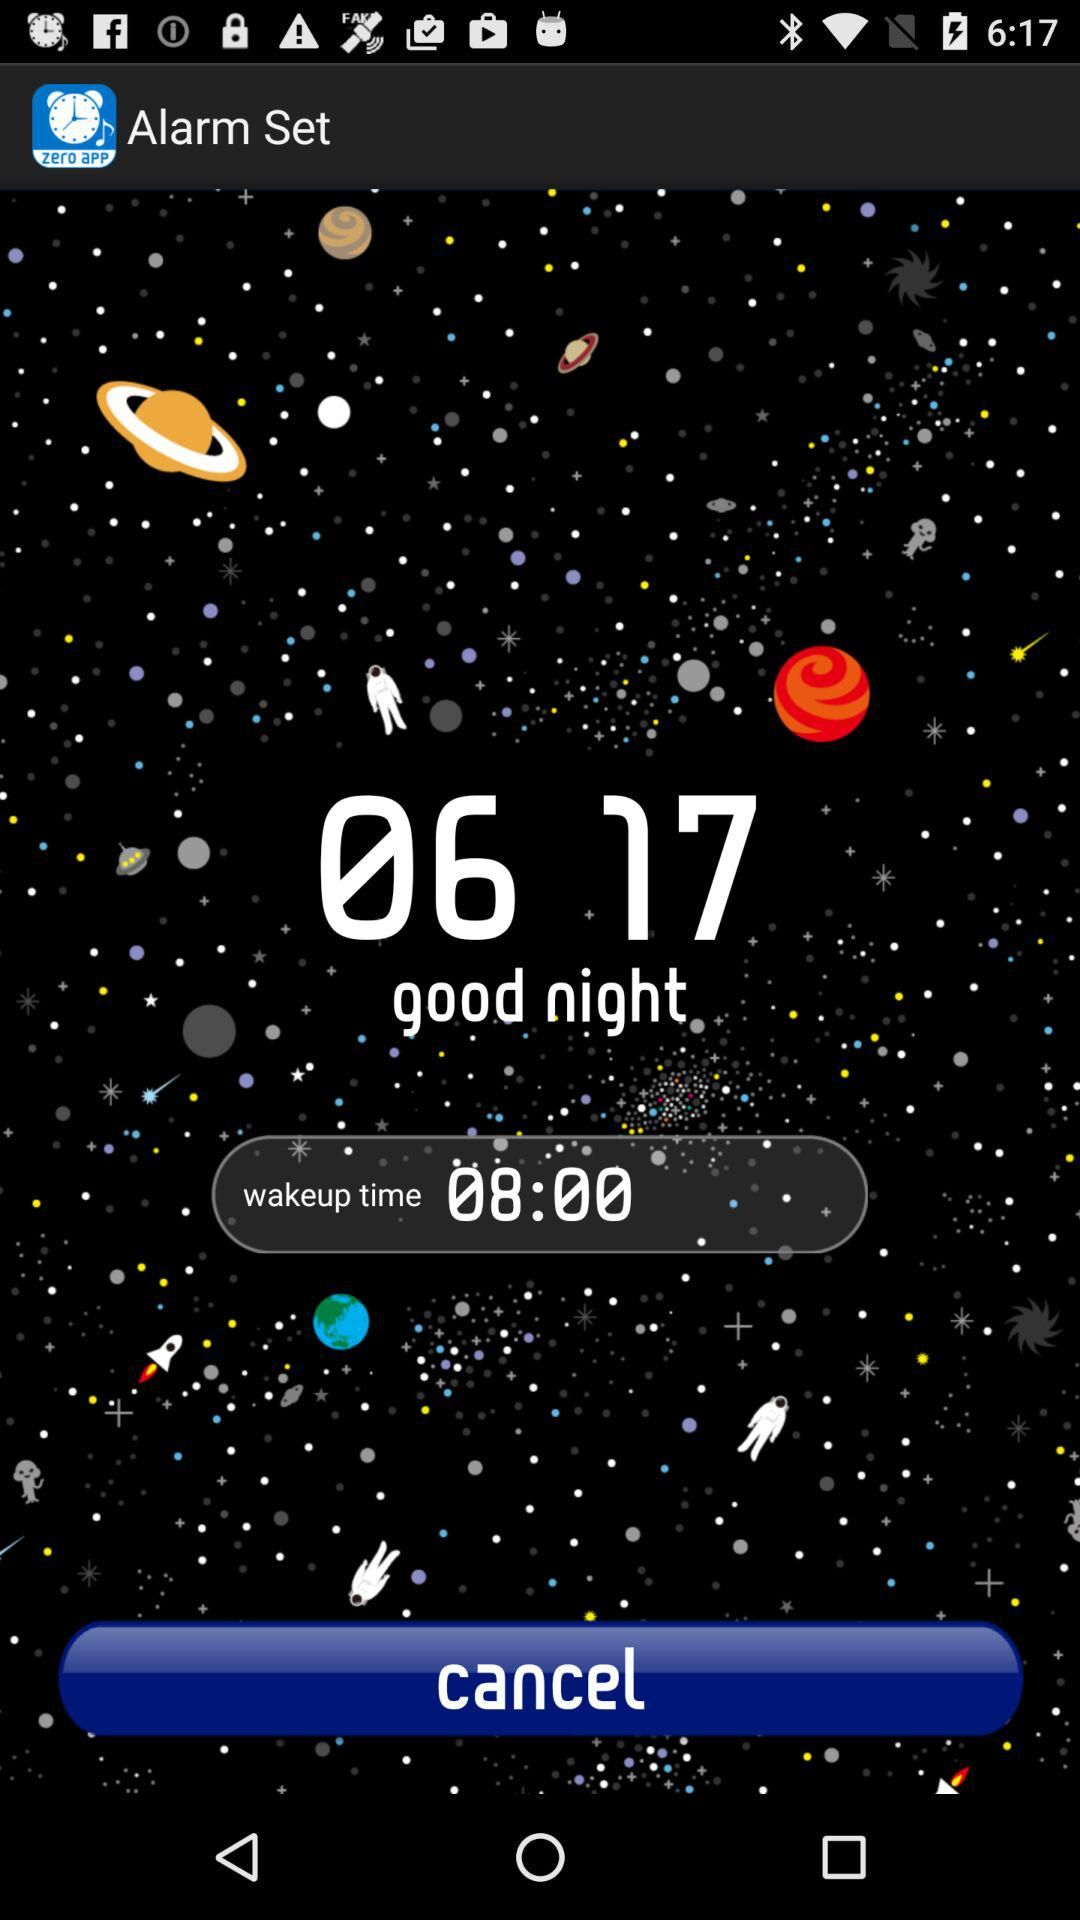For what wakeup time is the alarm set? The alarm is set for 08:00. 